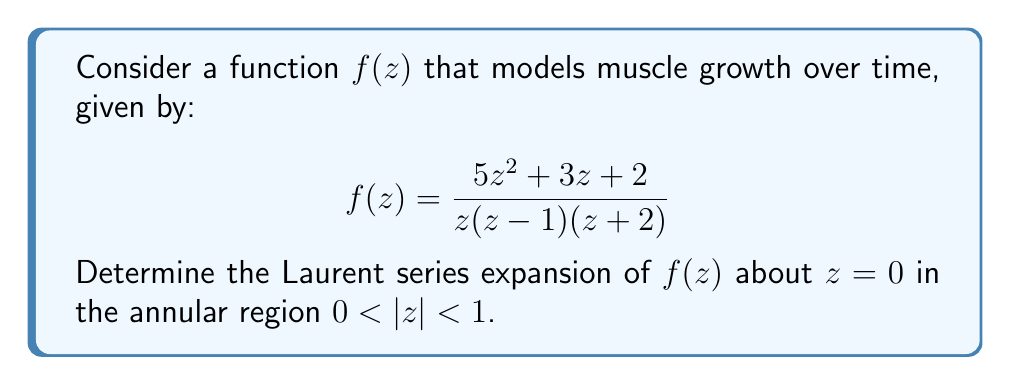Show me your answer to this math problem. To find the Laurent series expansion of $f(z)$ about $z=0$, we need to follow these steps:

1) First, let's perform partial fraction decomposition:

   $$f(z) = \frac{5z^2 + 3z + 2}{z(z-1)(z+2)} = \frac{A}{z} + \frac{B}{z-1} + \frac{C}{z+2}$$

2) Solving for A, B, and C:
   
   $$A = \lim_{z \to 0} zf(z) = \lim_{z \to 0} \frac{5z^2 + 3z + 2}{(z-1)(z+2)} = -1$$
   
   $$B = \lim_{z \to 1} (z-1)f(z) = \lim_{z \to 1} \frac{5z^2 + 3z + 2}{z(z+2)} = \frac{10}{3}$$
   
   $$C = \lim_{z \to -2} (z+2)f(z) = \lim_{z \to -2} \frac{5z^2 + 3z + 2}{z(z-1)} = -\frac{7}{3}$$

3) Therefore, 

   $$f(z) = -\frac{1}{z} + \frac{10/3}{z-1} - \frac{7/3}{z+2}$$

4) Now, we need to expand each term in a series valid for $0 < |z| < 1$:

   For $-\frac{1}{z}$, it's already in the correct form.

   For $\frac{10/3}{z-1}$, we use the geometric series:
   $$\frac{10/3}{z-1} = -\frac{10}{3} \cdot \frac{1}{1-z} = -\frac{10}{3}(1 + z + z^2 + z^3 + ...)$$

   For $-\frac{7/3}{z+2}$, we use the binomial series:
   $$-\frac{7/3}{z+2} = -\frac{7}{6} \cdot \frac{1}{1+z/2} = -\frac{7}{6}(1 - \frac{z}{2} + \frac{z^2}{4} - \frac{z^3}{8} + ...)$$

5) Combining all terms:

   $$f(z) = -\frac{1}{z} - \frac{10}{3} - \frac{7}{6} + (-\frac{10}{3} + \frac{7}{12})z + (-\frac{10}{3} - \frac{7}{24})z^2 + (-\frac{10}{3} + \frac{7}{48})z^3 + ...$$

6) Simplifying:

   $$f(z) = -\frac{1}{z} - \frac{25}{6} - \frac{33}{12}z - \frac{83}{24}z^2 - \frac{163}{48}z^3 + ...$$

This is the Laurent series expansion of $f(z)$ about $z=0$ in the annular region $0 < |z| < 1$.
Answer: The Laurent series expansion of $f(z)$ about $z=0$ in the annular region $0 < |z| < 1$ is:

$$f(z) = -\frac{1}{z} - \frac{25}{6} - \frac{33}{12}z - \frac{83}{24}z^2 - \frac{163}{48}z^3 + ...$$ 